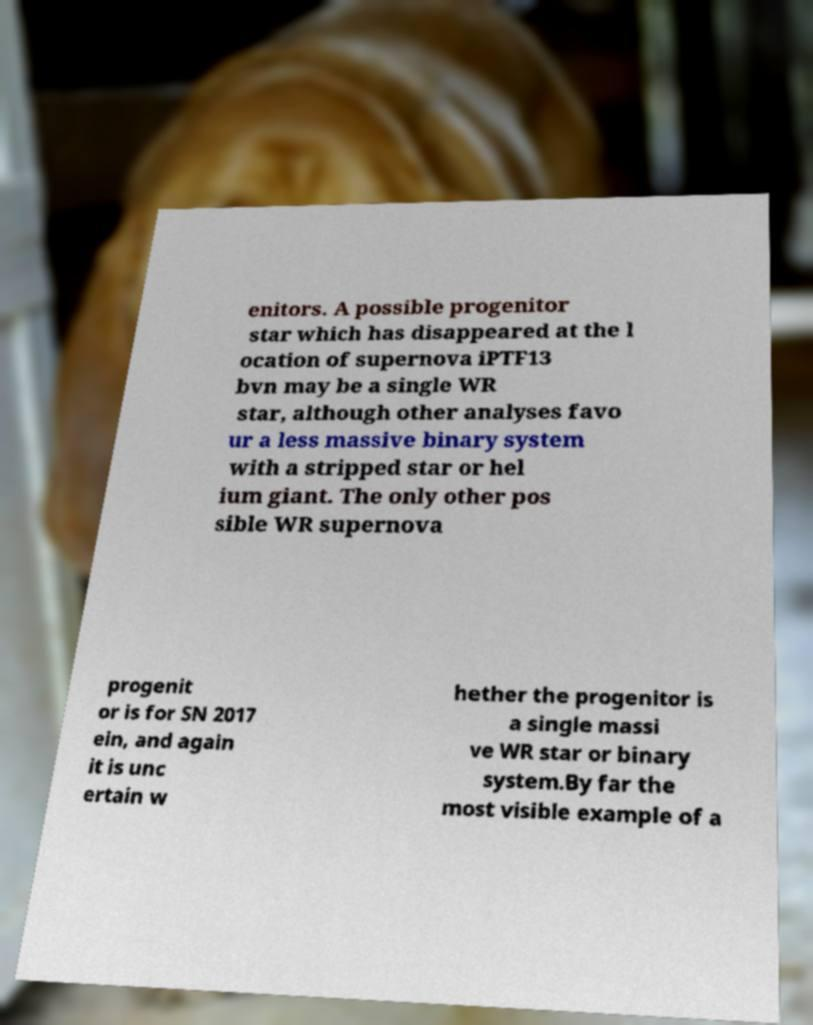What messages or text are displayed in this image? I need them in a readable, typed format. enitors. A possible progenitor star which has disappeared at the l ocation of supernova iPTF13 bvn may be a single WR star, although other analyses favo ur a less massive binary system with a stripped star or hel ium giant. The only other pos sible WR supernova progenit or is for SN 2017 ein, and again it is unc ertain w hether the progenitor is a single massi ve WR star or binary system.By far the most visible example of a 